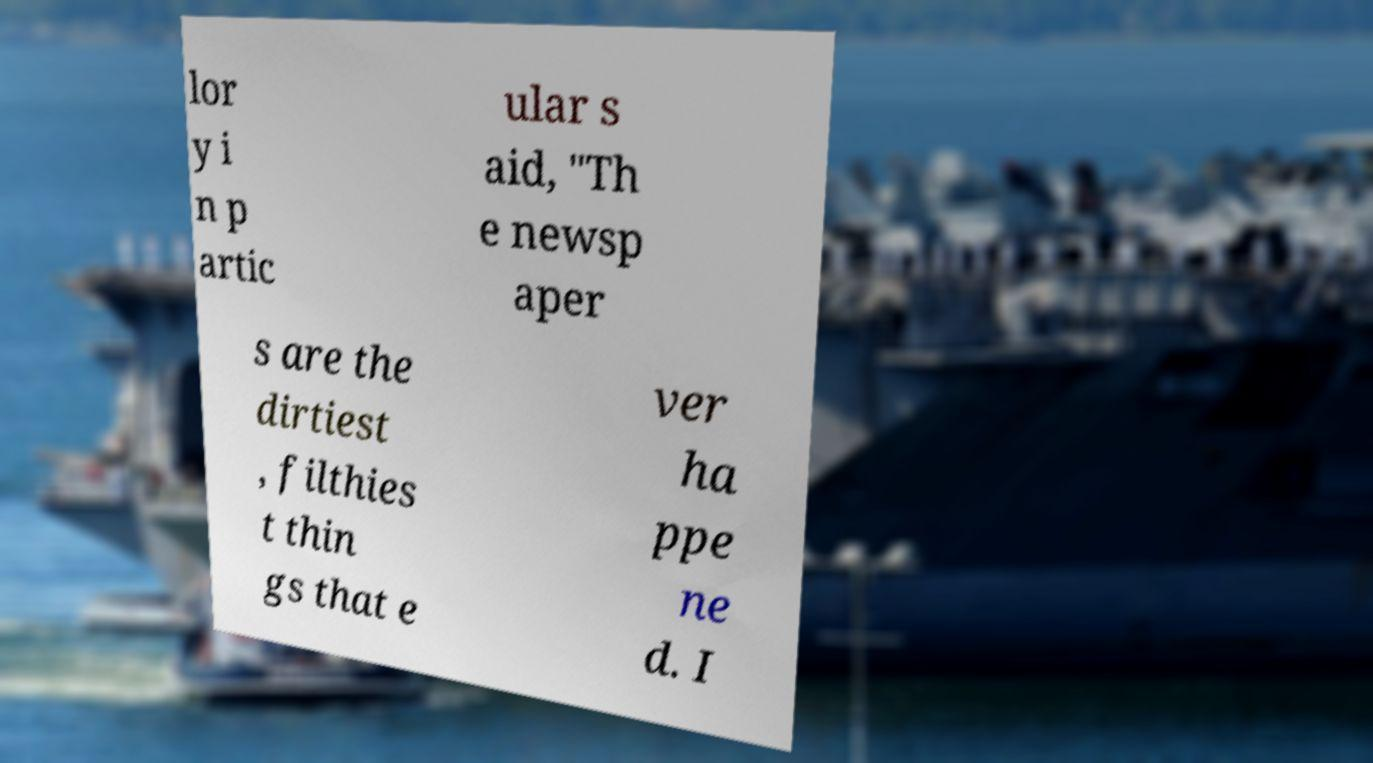For documentation purposes, I need the text within this image transcribed. Could you provide that? lor y i n p artic ular s aid, "Th e newsp aper s are the dirtiest , filthies t thin gs that e ver ha ppe ne d. I 